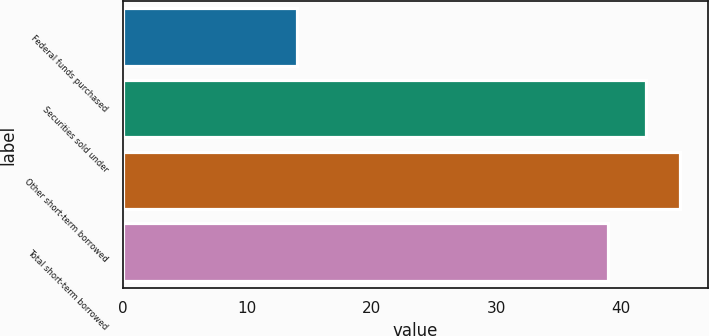Convert chart to OTSL. <chart><loc_0><loc_0><loc_500><loc_500><bar_chart><fcel>Federal funds purchased<fcel>Securities sold under<fcel>Other short-term borrowed<fcel>Total short-term borrowed<nl><fcel>14<fcel>42<fcel>44.8<fcel>39<nl></chart> 